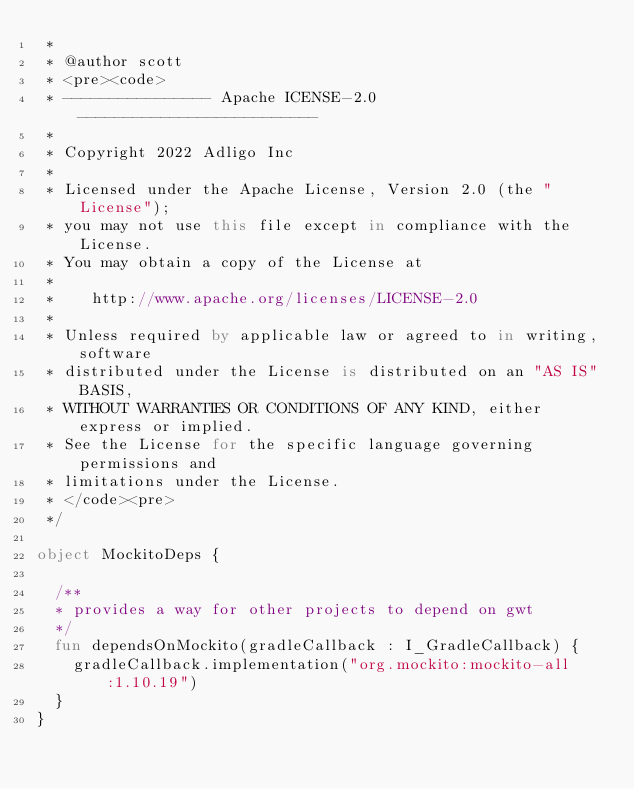Convert code to text. <code><loc_0><loc_0><loc_500><loc_500><_Kotlin_> *
 * @author scott
 * <pre><code>
 * ---------------- Apache ICENSE-2.0 --------------------------
 *
 * Copyright 2022 Adligo Inc
 * 
 * Licensed under the Apache License, Version 2.0 (the "License");
 * you may not use this file except in compliance with the License.
 * You may obtain a copy of the License at
 * 
 *    http://www.apache.org/licenses/LICENSE-2.0
 * 
 * Unless required by applicable law or agreed to in writing, software
 * distributed under the License is distributed on an "AS IS" BASIS,
 * WITHOUT WARRANTIES OR CONDITIONS OF ANY KIND, either express or implied.
 * See the License for the specific language governing permissions and
 * limitations under the License.
 * </code><pre>
 */
 
object MockitoDeps {

  /**
  * provides a way for other projects to depend on gwt
  */
  fun dependsOnMockito(gradleCallback : I_GradleCallback) {
    gradleCallback.implementation("org.mockito:mockito-all:1.10.19")
  }
}
</code> 